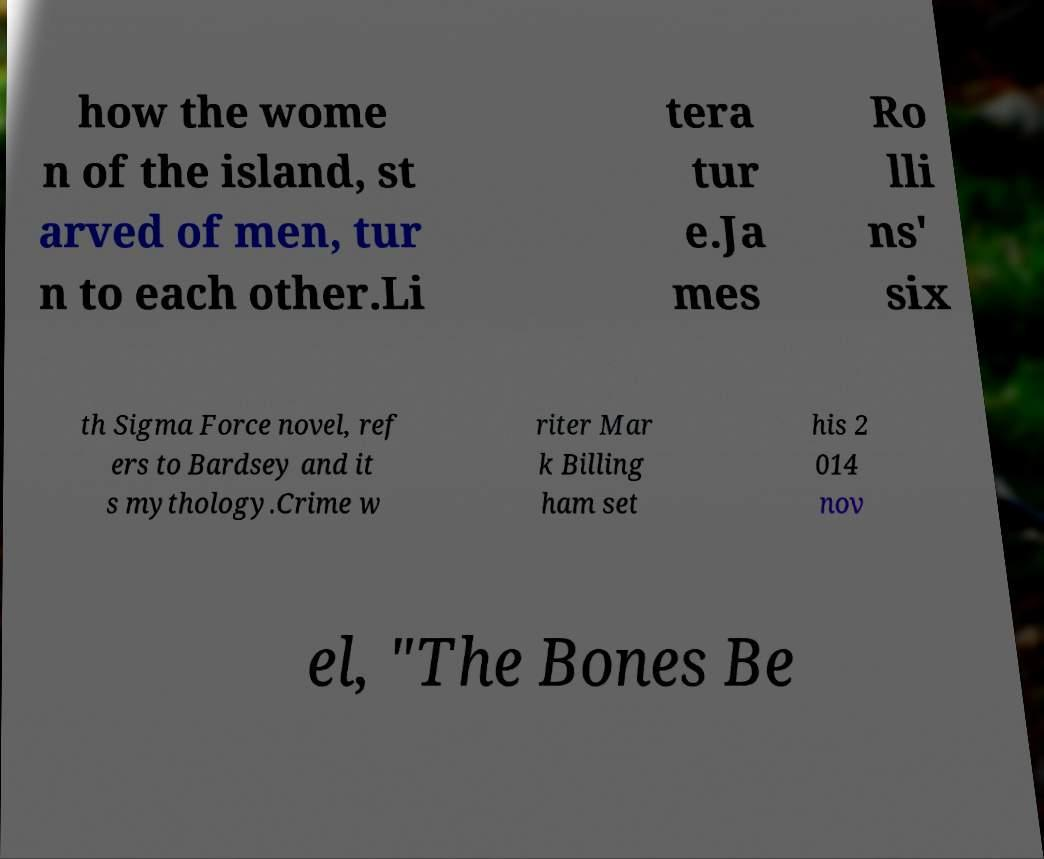I need the written content from this picture converted into text. Can you do that? how the wome n of the island, st arved of men, tur n to each other.Li tera tur e.Ja mes Ro lli ns' six th Sigma Force novel, ref ers to Bardsey and it s mythology.Crime w riter Mar k Billing ham set his 2 014 nov el, "The Bones Be 